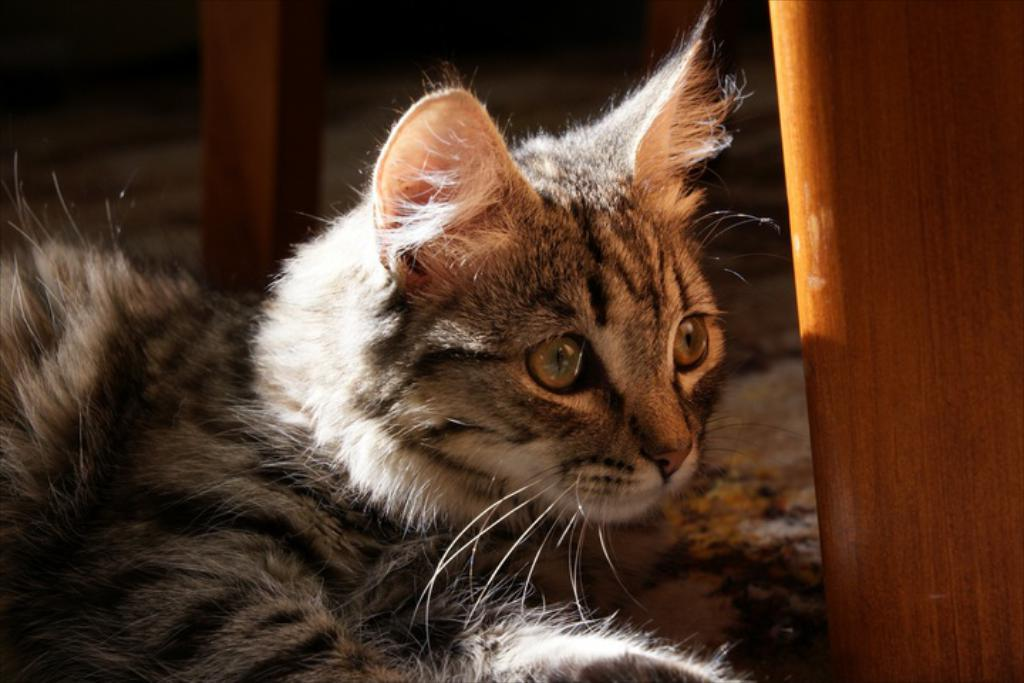What type of animal is in the image? There is a cat in the image. What object can be seen on the right side of the image? There is a piece of wood on the right side of the image. What is located in the top left of the image? There is a wooden pole in the top left of the image. What type of rail can be seen in the image? There is no rail present in the image. How does the cat crush the wooden pole in the image? The cat does not crush the wooden pole in the image; it is not interacting with the pole in any way. 